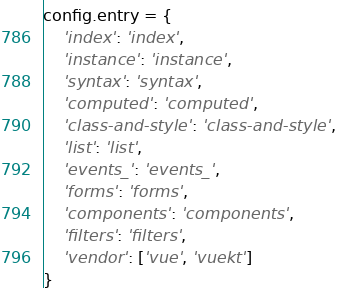<code> <loc_0><loc_0><loc_500><loc_500><_JavaScript_>config.entry = {
    'index': 'index',
    'instance': 'instance',
    'syntax': 'syntax',
    'computed': 'computed',
    'class-and-style': 'class-and-style',
    'list': 'list',
    'events_': 'events_',
    'forms': 'forms',
    'components': 'components',
    'filters': 'filters',
    'vendor': ['vue', 'vuekt']
}
</code> 